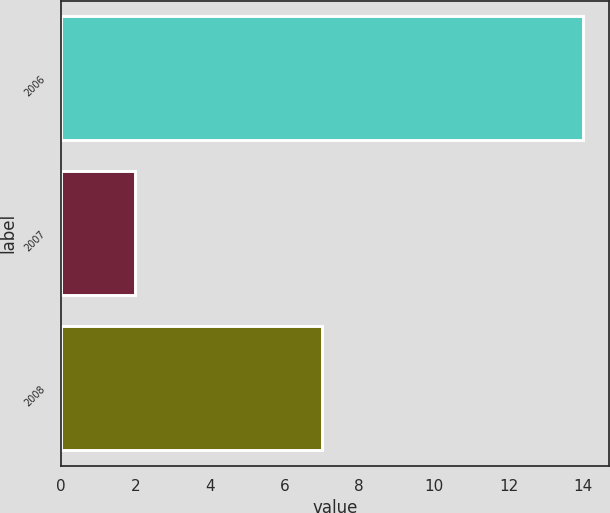<chart> <loc_0><loc_0><loc_500><loc_500><bar_chart><fcel>2006<fcel>2007<fcel>2008<nl><fcel>14<fcel>2<fcel>7<nl></chart> 